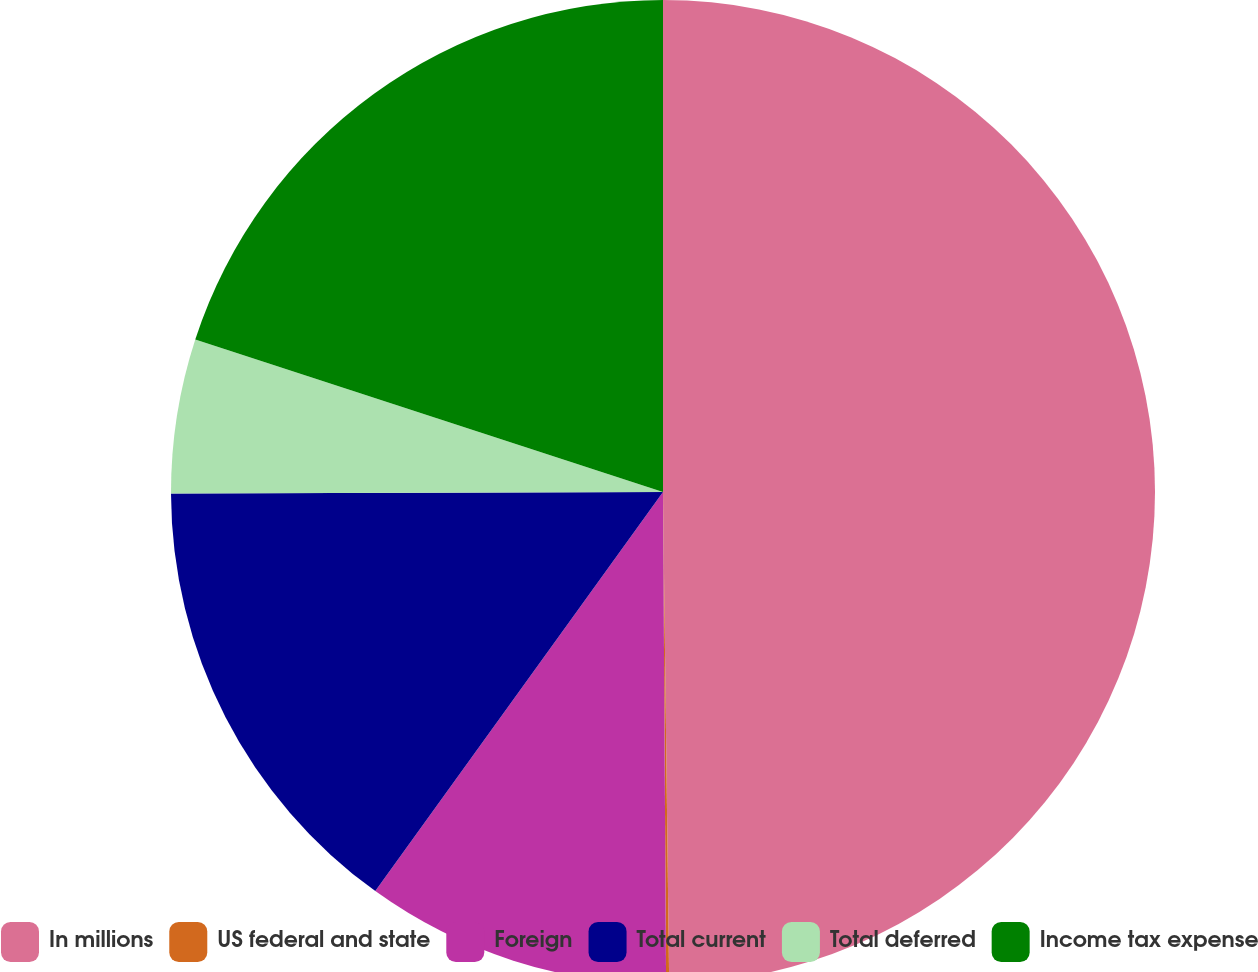Convert chart to OTSL. <chart><loc_0><loc_0><loc_500><loc_500><pie_chart><fcel>In millions<fcel>US federal and state<fcel>Foreign<fcel>Total current<fcel>Total deferred<fcel>Income tax expense<nl><fcel>49.8%<fcel>0.1%<fcel>10.04%<fcel>15.01%<fcel>5.07%<fcel>19.98%<nl></chart> 